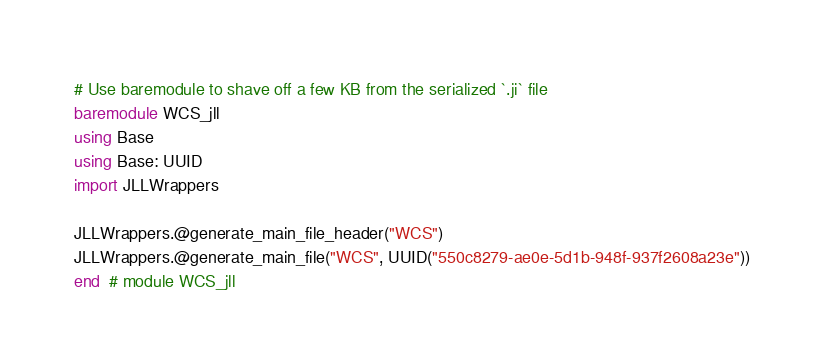Convert code to text. <code><loc_0><loc_0><loc_500><loc_500><_Julia_># Use baremodule to shave off a few KB from the serialized `.ji` file
baremodule WCS_jll
using Base
using Base: UUID
import JLLWrappers

JLLWrappers.@generate_main_file_header("WCS")
JLLWrappers.@generate_main_file("WCS", UUID("550c8279-ae0e-5d1b-948f-937f2608a23e"))
end  # module WCS_jll
</code> 